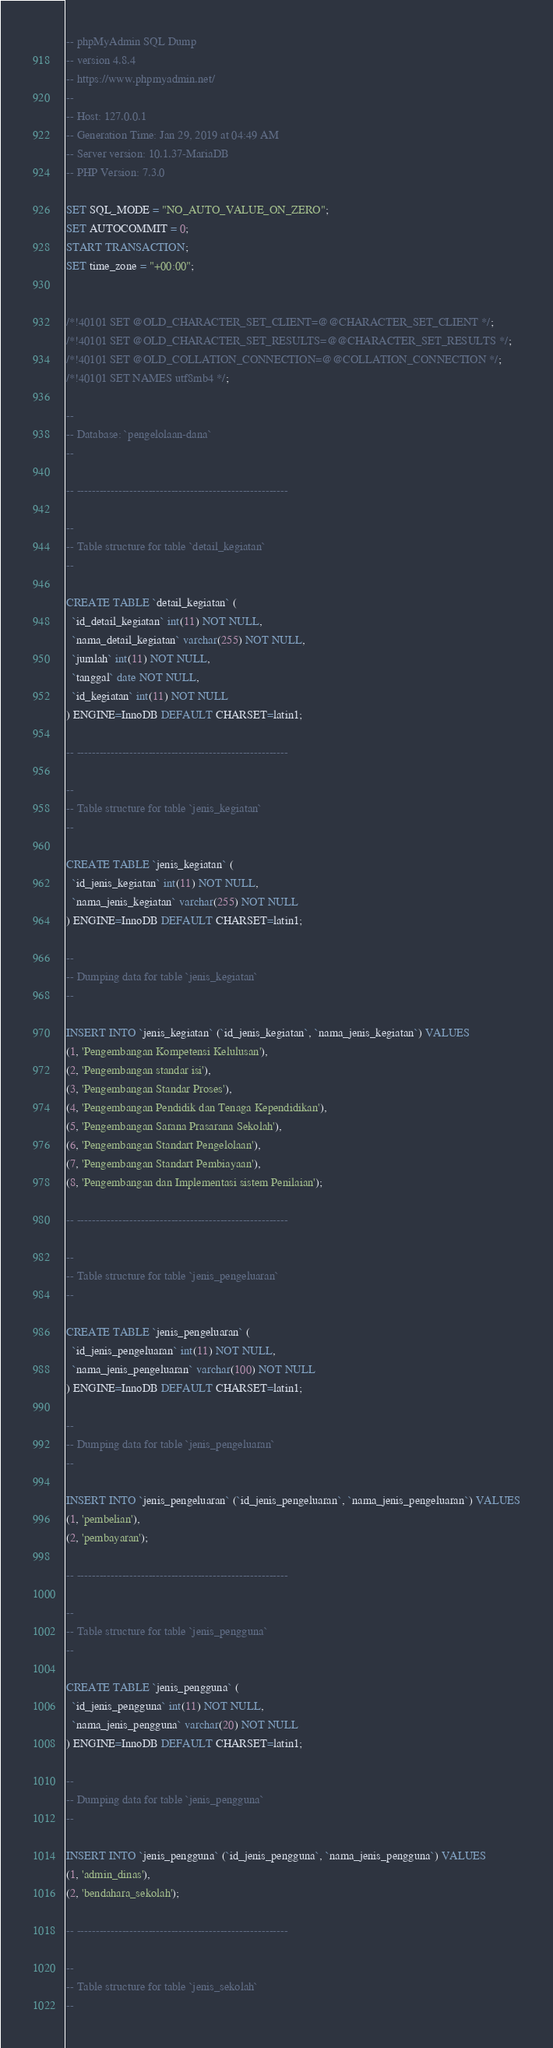Convert code to text. <code><loc_0><loc_0><loc_500><loc_500><_SQL_>-- phpMyAdmin SQL Dump
-- version 4.8.4
-- https://www.phpmyadmin.net/
--
-- Host: 127.0.0.1
-- Generation Time: Jan 29, 2019 at 04:49 AM
-- Server version: 10.1.37-MariaDB
-- PHP Version: 7.3.0

SET SQL_MODE = "NO_AUTO_VALUE_ON_ZERO";
SET AUTOCOMMIT = 0;
START TRANSACTION;
SET time_zone = "+00:00";


/*!40101 SET @OLD_CHARACTER_SET_CLIENT=@@CHARACTER_SET_CLIENT */;
/*!40101 SET @OLD_CHARACTER_SET_RESULTS=@@CHARACTER_SET_RESULTS */;
/*!40101 SET @OLD_COLLATION_CONNECTION=@@COLLATION_CONNECTION */;
/*!40101 SET NAMES utf8mb4 */;

--
-- Database: `pengelolaan-dana`
--

-- --------------------------------------------------------

--
-- Table structure for table `detail_kegiatan`
--

CREATE TABLE `detail_kegiatan` (
  `id_detail_kegiatan` int(11) NOT NULL,
  `nama_detail_kegiatan` varchar(255) NOT NULL,
  `jumlah` int(11) NOT NULL,
  `tanggal` date NOT NULL,
  `id_kegiatan` int(11) NOT NULL
) ENGINE=InnoDB DEFAULT CHARSET=latin1;

-- --------------------------------------------------------

--
-- Table structure for table `jenis_kegiatan`
--

CREATE TABLE `jenis_kegiatan` (
  `id_jenis_kegiatan` int(11) NOT NULL,
  `nama_jenis_kegiatan` varchar(255) NOT NULL
) ENGINE=InnoDB DEFAULT CHARSET=latin1;

--
-- Dumping data for table `jenis_kegiatan`
--

INSERT INTO `jenis_kegiatan` (`id_jenis_kegiatan`, `nama_jenis_kegiatan`) VALUES
(1, 'Pengembangan Kompetensi Kelulusan'),
(2, 'Pengembangan standar isi'),
(3, 'Pengembangan Standar Proses'),
(4, 'Pengembangan Pendidik dan Tenaga Kependidikan'),
(5, 'Pengembangan Sarana Prasarana Sekolah'),
(6, 'Pengembangan Standart Pengelolaan'),
(7, 'Pengembangan Standart Pembiayaan'),
(8, 'Pengembangan dan Implementasi sistem Penilaian');

-- --------------------------------------------------------

--
-- Table structure for table `jenis_pengeluaran`
--

CREATE TABLE `jenis_pengeluaran` (
  `id_jenis_pengeluaran` int(11) NOT NULL,
  `nama_jenis_pengeluaran` varchar(100) NOT NULL
) ENGINE=InnoDB DEFAULT CHARSET=latin1;

--
-- Dumping data for table `jenis_pengeluaran`
--

INSERT INTO `jenis_pengeluaran` (`id_jenis_pengeluaran`, `nama_jenis_pengeluaran`) VALUES
(1, 'pembelian'),
(2, 'pembayaran');

-- --------------------------------------------------------

--
-- Table structure for table `jenis_pengguna`
--

CREATE TABLE `jenis_pengguna` (
  `id_jenis_pengguna` int(11) NOT NULL,
  `nama_jenis_pengguna` varchar(20) NOT NULL
) ENGINE=InnoDB DEFAULT CHARSET=latin1;

--
-- Dumping data for table `jenis_pengguna`
--

INSERT INTO `jenis_pengguna` (`id_jenis_pengguna`, `nama_jenis_pengguna`) VALUES
(1, 'admin_dinas'),
(2, 'bendahara_sekolah');

-- --------------------------------------------------------

--
-- Table structure for table `jenis_sekolah`
--
</code> 